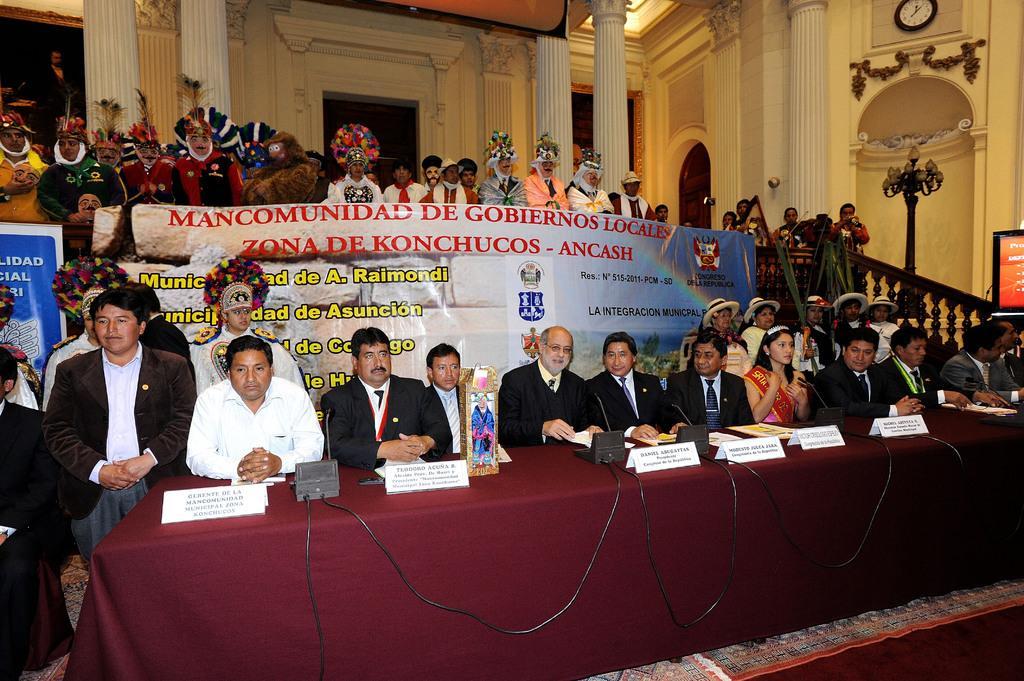In one or two sentences, can you explain what this image depicts? This picture shows a few people standing. They wore caps on their heads and few are seated and we see microphones and name boards on the table and we see a television on the side and lights to the pole and a wall clock. 